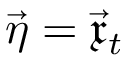Convert formula to latex. <formula><loc_0><loc_0><loc_500><loc_500>\vec { \eta } = \vec { \mathfrak { x } } _ { t }</formula> 